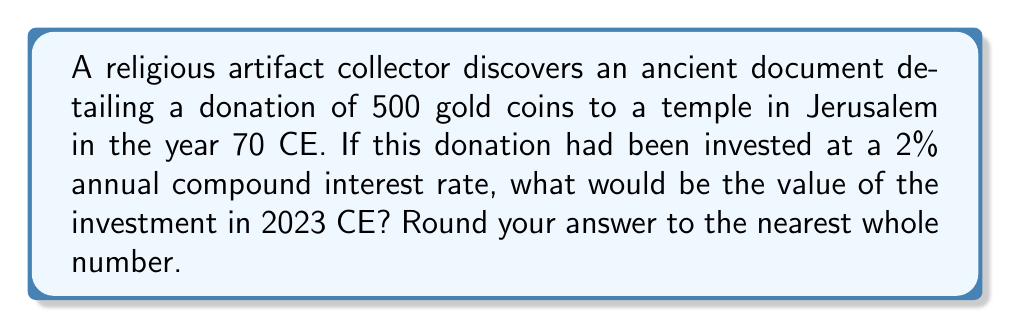Can you answer this question? To solve this problem, we'll use the compound interest formula:

$$ A = P(1 + r)^t $$

Where:
$A$ = Final amount
$P$ = Principal (initial investment)
$r$ = Annual interest rate (as a decimal)
$t$ = Time in years

Let's plug in our values:

$P = 500$ gold coins
$r = 0.02$ (2% converted to decimal)
$t = 2023 - 70 = 1953$ years

Now we can calculate:

$$ A = 500(1 + 0.02)^{1953} $$

Using a calculator or computer for this large exponent:

$$ A = 500 \times 6.901346 \times 10^{16} $$
$$ A = 3.450673 \times 10^{19} $$

Rounding to the nearest whole number:

$$ A \approx 34,506,730,000,000,000,000 $$

This incredibly large number demonstrates the power of compound interest over long periods, which could be used as a metaphor for how small acts of faith can grow exponentially over time in religious contexts.
Answer: 34,506,730,000,000,000,000 gold coins 